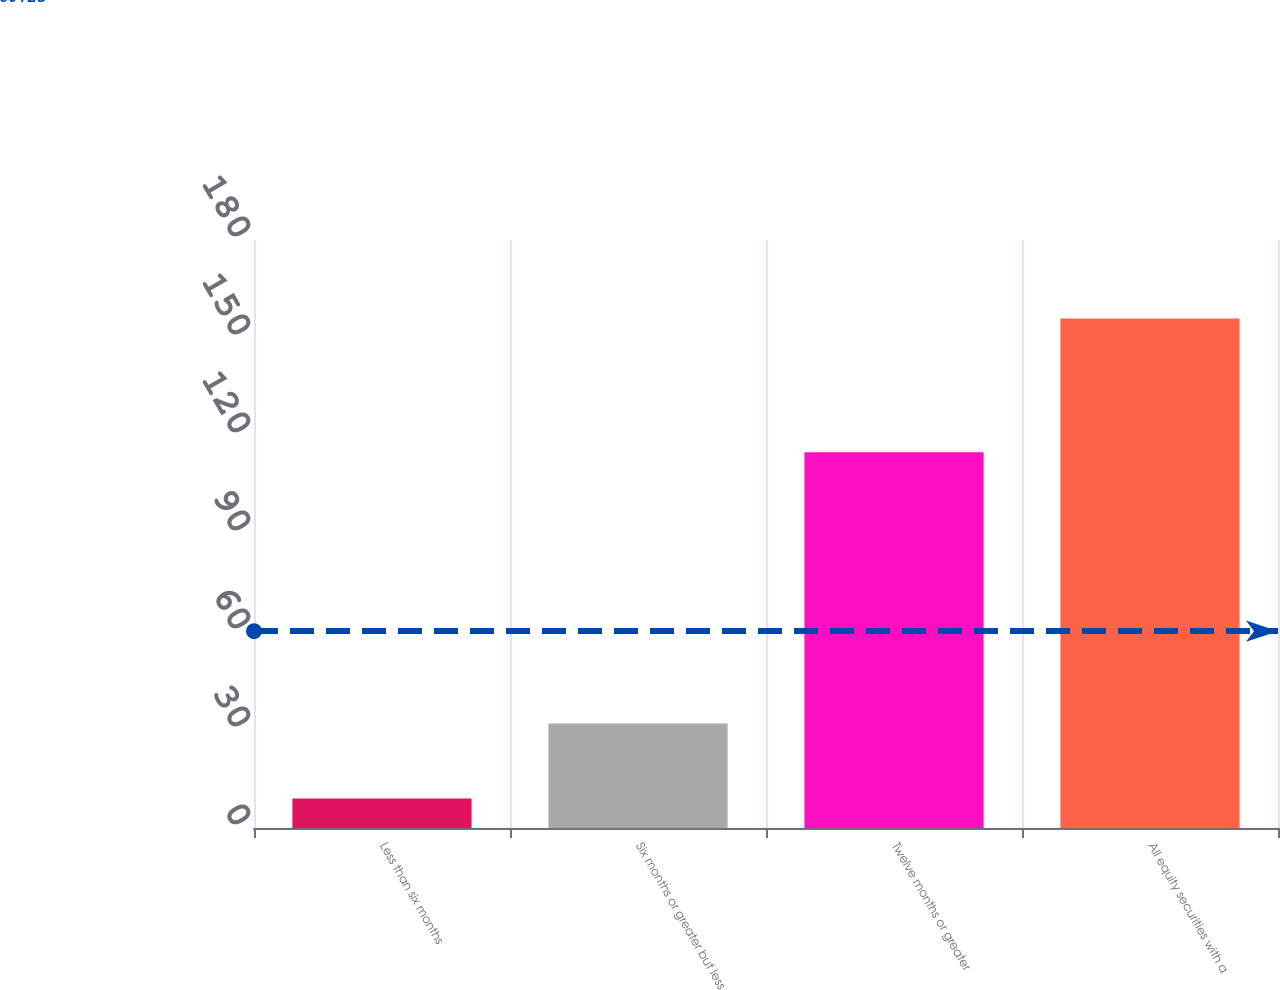<chart> <loc_0><loc_0><loc_500><loc_500><bar_chart><fcel>Less than six months<fcel>Six months or greater but less<fcel>Twelve months or greater<fcel>All equity securities with a<nl><fcel>9<fcel>32<fcel>115<fcel>156<nl></chart> 